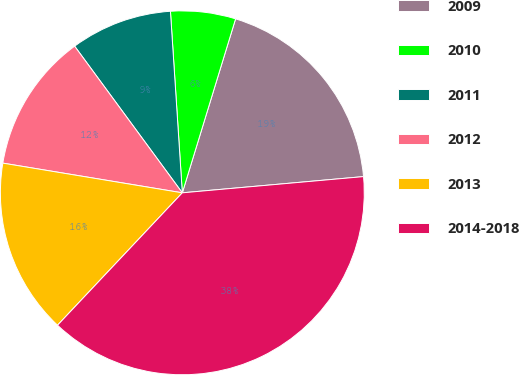<chart> <loc_0><loc_0><loc_500><loc_500><pie_chart><fcel>2009<fcel>2010<fcel>2011<fcel>2012<fcel>2013<fcel>2014-2018<nl><fcel>18.85%<fcel>5.77%<fcel>9.04%<fcel>12.31%<fcel>15.58%<fcel>38.45%<nl></chart> 